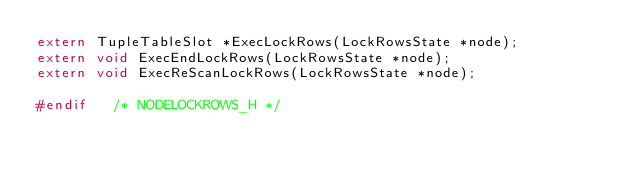Convert code to text. <code><loc_0><loc_0><loc_500><loc_500><_C_>extern TupleTableSlot *ExecLockRows(LockRowsState *node);
extern void ExecEndLockRows(LockRowsState *node);
extern void ExecReScanLockRows(LockRowsState *node);

#endif   /* NODELOCKROWS_H */
</code> 